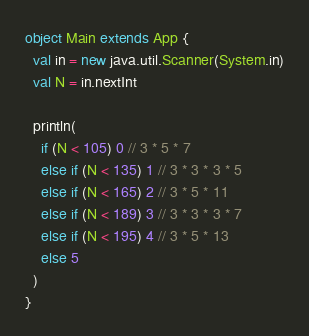Convert code to text. <code><loc_0><loc_0><loc_500><loc_500><_Scala_>object Main extends App {
  val in = new java.util.Scanner(System.in)
  val N = in.nextInt

  println(
    if (N < 105) 0 // 3 * 5 * 7
    else if (N < 135) 1 // 3 * 3 * 3 * 5
    else if (N < 165) 2 // 3 * 5 * 11
    else if (N < 189) 3 // 3 * 3 * 3 * 7
    else if (N < 195) 4 // 3 * 5 * 13
    else 5
  )
}</code> 